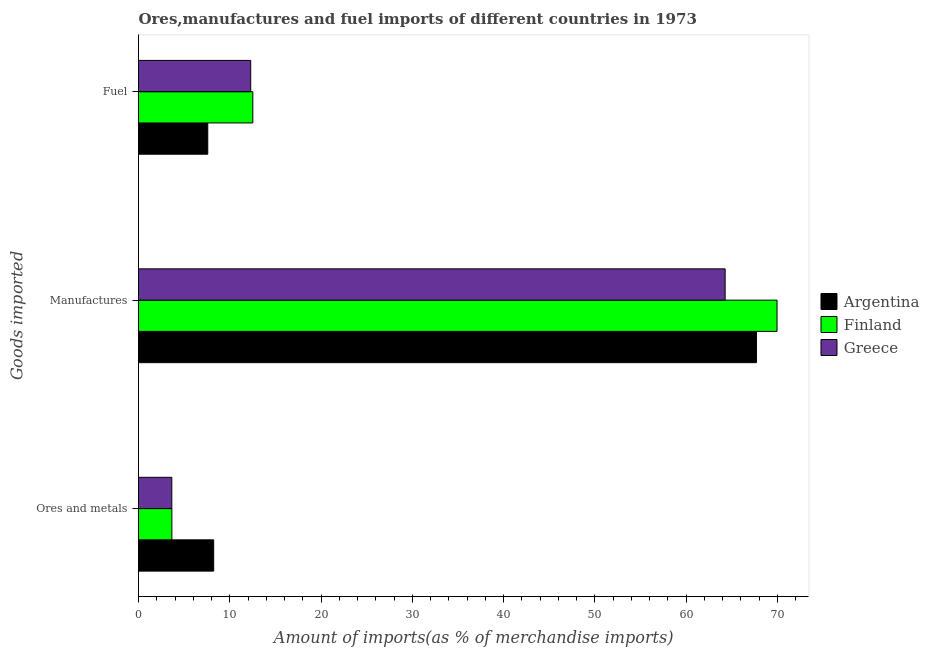How many different coloured bars are there?
Offer a very short reply. 3. Are the number of bars per tick equal to the number of legend labels?
Provide a succinct answer. Yes. What is the label of the 1st group of bars from the top?
Offer a very short reply. Fuel. What is the percentage of ores and metals imports in Finland?
Keep it short and to the point. 3.66. Across all countries, what is the maximum percentage of ores and metals imports?
Offer a very short reply. 8.24. Across all countries, what is the minimum percentage of fuel imports?
Ensure brevity in your answer.  7.59. What is the total percentage of manufactures imports in the graph?
Give a very brief answer. 201.98. What is the difference between the percentage of ores and metals imports in Argentina and that in Finland?
Ensure brevity in your answer.  4.58. What is the difference between the percentage of fuel imports in Finland and the percentage of manufactures imports in Greece?
Make the answer very short. -51.76. What is the average percentage of manufactures imports per country?
Make the answer very short. 67.33. What is the difference between the percentage of manufactures imports and percentage of ores and metals imports in Argentina?
Your answer should be compact. 59.48. What is the ratio of the percentage of fuel imports in Argentina to that in Finland?
Ensure brevity in your answer.  0.61. Is the percentage of ores and metals imports in Finland less than that in Greece?
Your response must be concise. No. Is the difference between the percentage of fuel imports in Greece and Argentina greater than the difference between the percentage of manufactures imports in Greece and Argentina?
Give a very brief answer. Yes. What is the difference between the highest and the second highest percentage of ores and metals imports?
Keep it short and to the point. 4.58. What is the difference between the highest and the lowest percentage of ores and metals imports?
Provide a short and direct response. 4.59. Is the sum of the percentage of manufactures imports in Greece and Argentina greater than the maximum percentage of ores and metals imports across all countries?
Offer a terse response. Yes. What does the 2nd bar from the bottom in Ores and metals represents?
Offer a terse response. Finland. Is it the case that in every country, the sum of the percentage of ores and metals imports and percentage of manufactures imports is greater than the percentage of fuel imports?
Make the answer very short. Yes. What is the difference between two consecutive major ticks on the X-axis?
Your response must be concise. 10. Are the values on the major ticks of X-axis written in scientific E-notation?
Your answer should be very brief. No. Does the graph contain grids?
Your response must be concise. No. How many legend labels are there?
Offer a terse response. 3. How are the legend labels stacked?
Make the answer very short. Vertical. What is the title of the graph?
Offer a very short reply. Ores,manufactures and fuel imports of different countries in 1973. Does "High income: OECD" appear as one of the legend labels in the graph?
Ensure brevity in your answer.  No. What is the label or title of the X-axis?
Keep it short and to the point. Amount of imports(as % of merchandise imports). What is the label or title of the Y-axis?
Your answer should be compact. Goods imported. What is the Amount of imports(as % of merchandise imports) in Argentina in Ores and metals?
Offer a terse response. 8.24. What is the Amount of imports(as % of merchandise imports) of Finland in Ores and metals?
Offer a terse response. 3.66. What is the Amount of imports(as % of merchandise imports) of Greece in Ores and metals?
Make the answer very short. 3.65. What is the Amount of imports(as % of merchandise imports) in Argentina in Manufactures?
Provide a short and direct response. 67.72. What is the Amount of imports(as % of merchandise imports) in Finland in Manufactures?
Ensure brevity in your answer.  69.97. What is the Amount of imports(as % of merchandise imports) of Greece in Manufactures?
Give a very brief answer. 64.29. What is the Amount of imports(as % of merchandise imports) of Argentina in Fuel?
Your response must be concise. 7.59. What is the Amount of imports(as % of merchandise imports) in Finland in Fuel?
Provide a short and direct response. 12.52. What is the Amount of imports(as % of merchandise imports) of Greece in Fuel?
Keep it short and to the point. 12.29. Across all Goods imported, what is the maximum Amount of imports(as % of merchandise imports) in Argentina?
Ensure brevity in your answer.  67.72. Across all Goods imported, what is the maximum Amount of imports(as % of merchandise imports) in Finland?
Provide a short and direct response. 69.97. Across all Goods imported, what is the maximum Amount of imports(as % of merchandise imports) of Greece?
Provide a succinct answer. 64.29. Across all Goods imported, what is the minimum Amount of imports(as % of merchandise imports) of Argentina?
Provide a succinct answer. 7.59. Across all Goods imported, what is the minimum Amount of imports(as % of merchandise imports) of Finland?
Your answer should be very brief. 3.66. Across all Goods imported, what is the minimum Amount of imports(as % of merchandise imports) of Greece?
Provide a short and direct response. 3.65. What is the total Amount of imports(as % of merchandise imports) of Argentina in the graph?
Make the answer very short. 83.55. What is the total Amount of imports(as % of merchandise imports) of Finland in the graph?
Offer a very short reply. 86.15. What is the total Amount of imports(as % of merchandise imports) of Greece in the graph?
Ensure brevity in your answer.  80.23. What is the difference between the Amount of imports(as % of merchandise imports) in Argentina in Ores and metals and that in Manufactures?
Provide a succinct answer. -59.48. What is the difference between the Amount of imports(as % of merchandise imports) of Finland in Ores and metals and that in Manufactures?
Your answer should be compact. -66.32. What is the difference between the Amount of imports(as % of merchandise imports) of Greece in Ores and metals and that in Manufactures?
Keep it short and to the point. -60.63. What is the difference between the Amount of imports(as % of merchandise imports) in Argentina in Ores and metals and that in Fuel?
Your answer should be very brief. 0.65. What is the difference between the Amount of imports(as % of merchandise imports) in Finland in Ores and metals and that in Fuel?
Offer a terse response. -8.87. What is the difference between the Amount of imports(as % of merchandise imports) in Greece in Ores and metals and that in Fuel?
Provide a succinct answer. -8.64. What is the difference between the Amount of imports(as % of merchandise imports) of Argentina in Manufactures and that in Fuel?
Give a very brief answer. 60.13. What is the difference between the Amount of imports(as % of merchandise imports) of Finland in Manufactures and that in Fuel?
Give a very brief answer. 57.45. What is the difference between the Amount of imports(as % of merchandise imports) of Greece in Manufactures and that in Fuel?
Provide a short and direct response. 51.99. What is the difference between the Amount of imports(as % of merchandise imports) in Argentina in Ores and metals and the Amount of imports(as % of merchandise imports) in Finland in Manufactures?
Offer a very short reply. -61.74. What is the difference between the Amount of imports(as % of merchandise imports) of Argentina in Ores and metals and the Amount of imports(as % of merchandise imports) of Greece in Manufactures?
Keep it short and to the point. -56.05. What is the difference between the Amount of imports(as % of merchandise imports) of Finland in Ores and metals and the Amount of imports(as % of merchandise imports) of Greece in Manufactures?
Make the answer very short. -60.63. What is the difference between the Amount of imports(as % of merchandise imports) of Argentina in Ores and metals and the Amount of imports(as % of merchandise imports) of Finland in Fuel?
Make the answer very short. -4.29. What is the difference between the Amount of imports(as % of merchandise imports) of Argentina in Ores and metals and the Amount of imports(as % of merchandise imports) of Greece in Fuel?
Ensure brevity in your answer.  -4.06. What is the difference between the Amount of imports(as % of merchandise imports) in Finland in Ores and metals and the Amount of imports(as % of merchandise imports) in Greece in Fuel?
Give a very brief answer. -8.64. What is the difference between the Amount of imports(as % of merchandise imports) in Argentina in Manufactures and the Amount of imports(as % of merchandise imports) in Finland in Fuel?
Your response must be concise. 55.19. What is the difference between the Amount of imports(as % of merchandise imports) of Argentina in Manufactures and the Amount of imports(as % of merchandise imports) of Greece in Fuel?
Your answer should be very brief. 55.43. What is the difference between the Amount of imports(as % of merchandise imports) in Finland in Manufactures and the Amount of imports(as % of merchandise imports) in Greece in Fuel?
Offer a very short reply. 57.68. What is the average Amount of imports(as % of merchandise imports) of Argentina per Goods imported?
Offer a very short reply. 27.85. What is the average Amount of imports(as % of merchandise imports) of Finland per Goods imported?
Ensure brevity in your answer.  28.72. What is the average Amount of imports(as % of merchandise imports) in Greece per Goods imported?
Give a very brief answer. 26.74. What is the difference between the Amount of imports(as % of merchandise imports) of Argentina and Amount of imports(as % of merchandise imports) of Finland in Ores and metals?
Keep it short and to the point. 4.58. What is the difference between the Amount of imports(as % of merchandise imports) in Argentina and Amount of imports(as % of merchandise imports) in Greece in Ores and metals?
Offer a very short reply. 4.59. What is the difference between the Amount of imports(as % of merchandise imports) in Finland and Amount of imports(as % of merchandise imports) in Greece in Ores and metals?
Your answer should be very brief. 0.01. What is the difference between the Amount of imports(as % of merchandise imports) of Argentina and Amount of imports(as % of merchandise imports) of Finland in Manufactures?
Your answer should be very brief. -2.25. What is the difference between the Amount of imports(as % of merchandise imports) of Argentina and Amount of imports(as % of merchandise imports) of Greece in Manufactures?
Ensure brevity in your answer.  3.43. What is the difference between the Amount of imports(as % of merchandise imports) in Finland and Amount of imports(as % of merchandise imports) in Greece in Manufactures?
Give a very brief answer. 5.69. What is the difference between the Amount of imports(as % of merchandise imports) of Argentina and Amount of imports(as % of merchandise imports) of Finland in Fuel?
Keep it short and to the point. -4.94. What is the difference between the Amount of imports(as % of merchandise imports) of Argentina and Amount of imports(as % of merchandise imports) of Greece in Fuel?
Offer a terse response. -4.7. What is the difference between the Amount of imports(as % of merchandise imports) in Finland and Amount of imports(as % of merchandise imports) in Greece in Fuel?
Your answer should be very brief. 0.23. What is the ratio of the Amount of imports(as % of merchandise imports) in Argentina in Ores and metals to that in Manufactures?
Your response must be concise. 0.12. What is the ratio of the Amount of imports(as % of merchandise imports) of Finland in Ores and metals to that in Manufactures?
Keep it short and to the point. 0.05. What is the ratio of the Amount of imports(as % of merchandise imports) in Greece in Ores and metals to that in Manufactures?
Your response must be concise. 0.06. What is the ratio of the Amount of imports(as % of merchandise imports) in Argentina in Ores and metals to that in Fuel?
Offer a terse response. 1.09. What is the ratio of the Amount of imports(as % of merchandise imports) in Finland in Ores and metals to that in Fuel?
Your response must be concise. 0.29. What is the ratio of the Amount of imports(as % of merchandise imports) in Greece in Ores and metals to that in Fuel?
Make the answer very short. 0.3. What is the ratio of the Amount of imports(as % of merchandise imports) of Argentina in Manufactures to that in Fuel?
Your answer should be compact. 8.92. What is the ratio of the Amount of imports(as % of merchandise imports) in Finland in Manufactures to that in Fuel?
Keep it short and to the point. 5.59. What is the ratio of the Amount of imports(as % of merchandise imports) of Greece in Manufactures to that in Fuel?
Give a very brief answer. 5.23. What is the difference between the highest and the second highest Amount of imports(as % of merchandise imports) of Argentina?
Your response must be concise. 59.48. What is the difference between the highest and the second highest Amount of imports(as % of merchandise imports) of Finland?
Your answer should be very brief. 57.45. What is the difference between the highest and the second highest Amount of imports(as % of merchandise imports) of Greece?
Ensure brevity in your answer.  51.99. What is the difference between the highest and the lowest Amount of imports(as % of merchandise imports) of Argentina?
Ensure brevity in your answer.  60.13. What is the difference between the highest and the lowest Amount of imports(as % of merchandise imports) of Finland?
Your response must be concise. 66.32. What is the difference between the highest and the lowest Amount of imports(as % of merchandise imports) of Greece?
Ensure brevity in your answer.  60.63. 